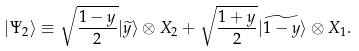Convert formula to latex. <formula><loc_0><loc_0><loc_500><loc_500>| \Psi _ { 2 } \rangle \equiv \sqrt { \frac { 1 - y } 2 } | \widetilde { y } \rangle \otimes X _ { 2 } + \sqrt { \frac { 1 + y } 2 } | \widetilde { 1 - y } \rangle \otimes X _ { 1 } .</formula> 